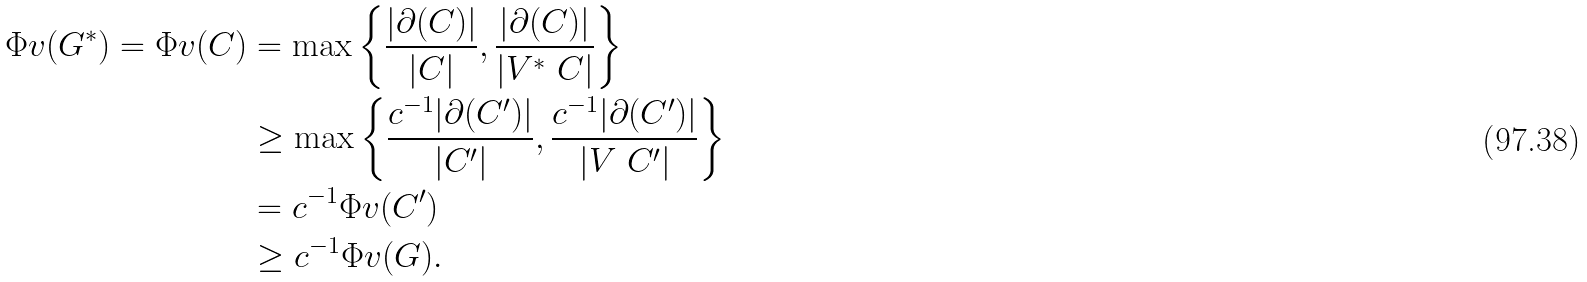Convert formula to latex. <formula><loc_0><loc_0><loc_500><loc_500>\Phi v ( G ^ { \ast } ) = \Phi v ( C ) & = \max \left \{ \frac { | \partial ( C ) | } { | C | } , \frac { | \partial ( C ) | } { | V ^ { \ast } \ C | } \right \} \\ & \geq \max \left \{ \frac { c ^ { - 1 } | \partial ( C ^ { \prime } ) | } { | C ^ { \prime } | } , \frac { c ^ { - 1 } | \partial ( C ^ { \prime } ) | } { | V \ C ^ { \prime } | } \right \} \\ & = c ^ { - 1 } \Phi v ( C ^ { \prime } ) \\ & \geq c ^ { - 1 } \Phi v ( G ) .</formula> 